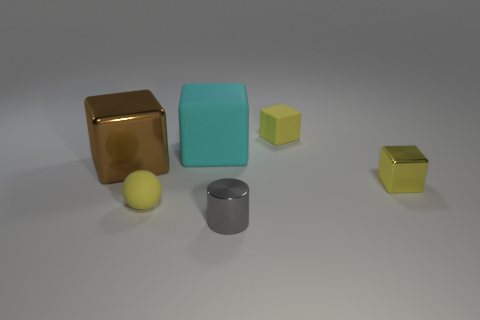Subtract all yellow matte cubes. How many cubes are left? 3 Add 1 green rubber balls. How many objects exist? 7 Subtract all yellow blocks. How many blocks are left? 2 Subtract all red cylinders. How many cyan cubes are left? 1 Subtract all small green rubber things. Subtract all small yellow objects. How many objects are left? 3 Add 6 big cubes. How many big cubes are left? 8 Add 4 big gray metallic things. How many big gray metallic things exist? 4 Subtract 1 gray cylinders. How many objects are left? 5 Subtract all blocks. How many objects are left? 2 Subtract 1 cubes. How many cubes are left? 3 